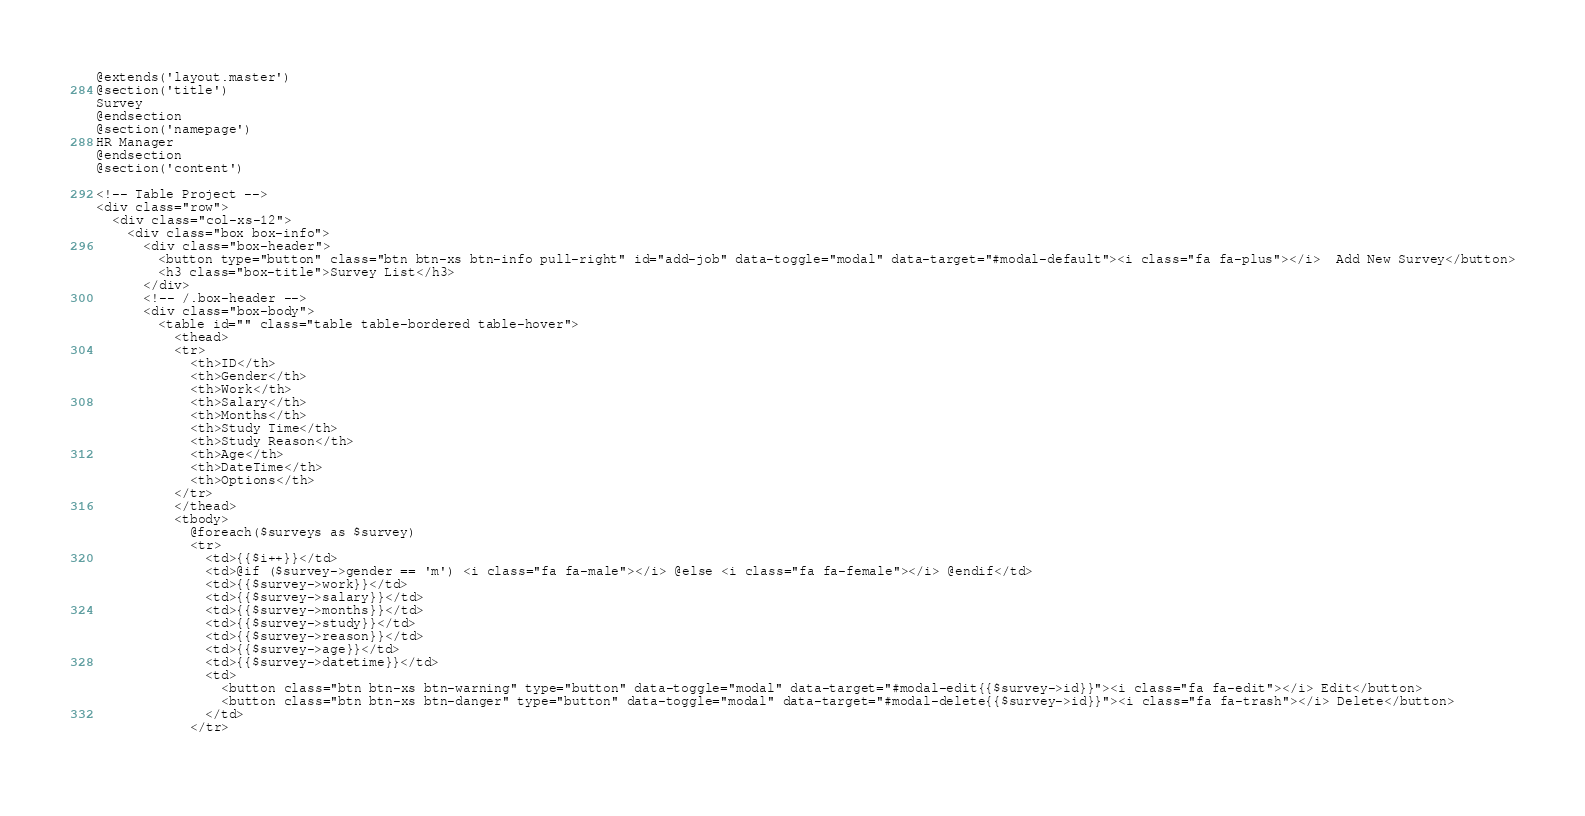<code> <loc_0><loc_0><loc_500><loc_500><_PHP_>@extends('layout.master')
@section('title')
Survey
@endsection
@section('namepage')
HR Manager
@endsection
@section('content')

<!-- Table Project -->
<div class="row">
  <div class="col-xs-12">
    <div class="box box-info">
      <div class="box-header">
        <button type="button" class="btn btn-xs btn-info pull-right" id="add-job" data-toggle="modal" data-target="#modal-default"><i class="fa fa-plus"></i>  Add New Survey</button>
        <h3 class="box-title">Survey List</h3>
      </div>
      <!-- /.box-header -->
      <div class="box-body">
        <table id="" class="table table-bordered table-hover">
          <thead>
          <tr>
			<th>ID</th>
            <th>Gender</th>
            <th>Work</th>
            <th>Salary</th>
            <th>Months</th>
            <th>Study Time</th>
            <th>Study Reason</th>
            <th>Age</th>
			<th>DateTime</th>
			<th>Options</th>
          </tr>
          </thead>
          <tbody>
            @foreach($surveys as $survey)
            <tr>
			  <td>{{$i++}}</td>
			  <td>@if ($survey->gender == 'm') <i class="fa fa-male"></i> @else <i class="fa fa-female"></i> @endif</td>
              <td>{{$survey->work}}</td>
              <td>{{$survey->salary}}</td>
              <td>{{$survey->months}}</td>
              <td>{{$survey->study}}</td>
              <td>{{$survey->reason}}</td>
              <td>{{$survey->age}}</td>
			  <td>{{$survey->datetime}}</td>
			  <td>
			  	<button class="btn btn-xs btn-warning" type="button" data-toggle="modal" data-target="#modal-edit{{$survey->id}}"><i class="fa fa-edit"></i> Edit</button>
			  	<button class="btn btn-xs btn-danger" type="button" data-toggle="modal" data-target="#modal-delete{{$survey->id}}"><i class="fa fa-trash"></i> Delete</button>
			  </td>
			</tr>
			</code> 